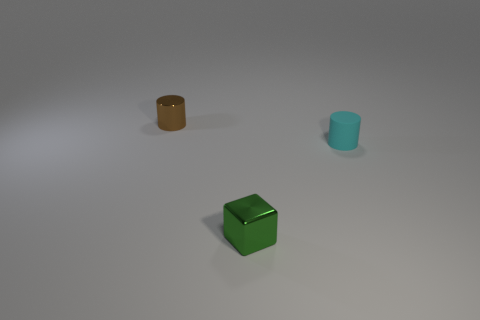Add 3 small brown balls. How many objects exist? 6 Subtract all cylinders. How many objects are left? 1 Add 2 small matte cylinders. How many small matte cylinders exist? 3 Subtract 0 gray blocks. How many objects are left? 3 Subtract all brown shiny balls. Subtract all tiny cyan cylinders. How many objects are left? 2 Add 3 tiny brown metal objects. How many tiny brown metal objects are left? 4 